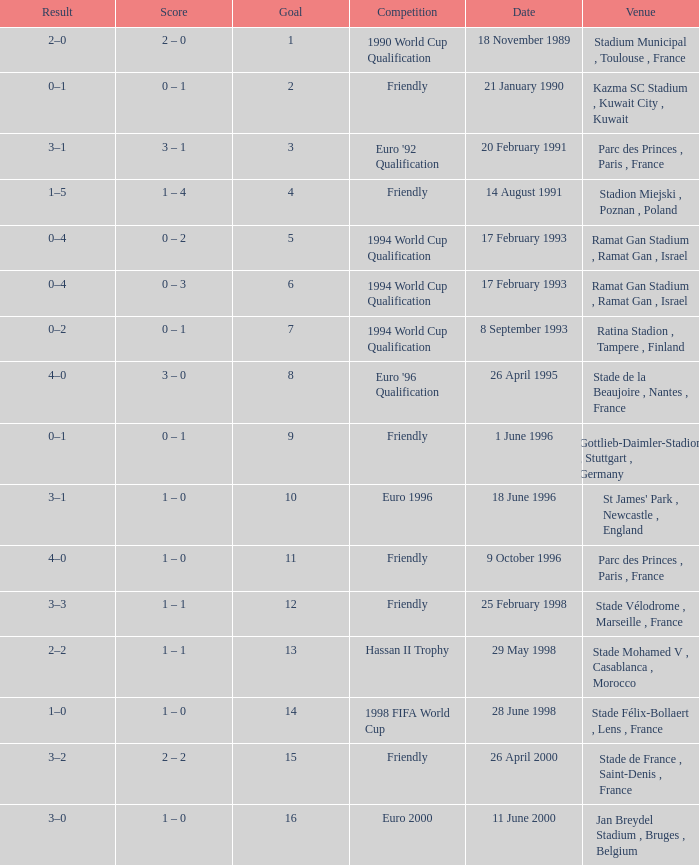Can you parse all the data within this table? {'header': ['Result', 'Score', 'Goal', 'Competition', 'Date', 'Venue'], 'rows': [['2–0', '2 – 0', '1', '1990 World Cup Qualification', '18 November 1989', 'Stadium Municipal , Toulouse , France'], ['0–1', '0 – 1', '2', 'Friendly', '21 January 1990', 'Kazma SC Stadium , Kuwait City , Kuwait'], ['3–1', '3 – 1', '3', "Euro '92 Qualification", '20 February 1991', 'Parc des Princes , Paris , France'], ['1–5', '1 – 4', '4', 'Friendly', '14 August 1991', 'Stadion Miejski , Poznan , Poland'], ['0–4', '0 – 2', '5', '1994 World Cup Qualification', '17 February 1993', 'Ramat Gan Stadium , Ramat Gan , Israel'], ['0–4', '0 – 3', '6', '1994 World Cup Qualification', '17 February 1993', 'Ramat Gan Stadium , Ramat Gan , Israel'], ['0–2', '0 – 1', '7', '1994 World Cup Qualification', '8 September 1993', 'Ratina Stadion , Tampere , Finland'], ['4–0', '3 – 0', '8', "Euro '96 Qualification", '26 April 1995', 'Stade de la Beaujoire , Nantes , France'], ['0–1', '0 – 1', '9', 'Friendly', '1 June 1996', 'Gottlieb-Daimler-Stadion , Stuttgart , Germany'], ['3–1', '1 – 0', '10', 'Euro 1996', '18 June 1996', "St James' Park , Newcastle , England"], ['4–0', '1 – 0', '11', 'Friendly', '9 October 1996', 'Parc des Princes , Paris , France'], ['3–3', '1 – 1', '12', 'Friendly', '25 February 1998', 'Stade Vélodrome , Marseille , France'], ['2–2', '1 – 1', '13', 'Hassan II Trophy', '29 May 1998', 'Stade Mohamed V , Casablanca , Morocco'], ['1–0', '1 – 0', '14', '1998 FIFA World Cup', '28 June 1998', 'Stade Félix-Bollaert , Lens , France'], ['3–2', '2 – 2', '15', 'Friendly', '26 April 2000', 'Stade de France , Saint-Denis , France'], ['3–0', '1 – 0', '16', 'Euro 2000', '11 June 2000', 'Jan Breydel Stadium , Bruges , Belgium']]} What was the date of the game with a result of 3–2? 26 April 2000. 